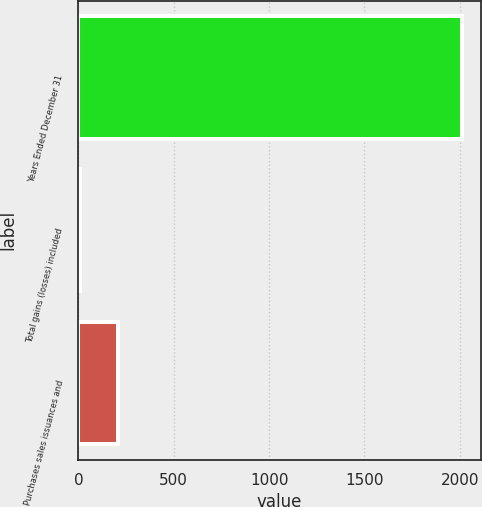Convert chart to OTSL. <chart><loc_0><loc_0><loc_500><loc_500><bar_chart><fcel>Years Ended December 31<fcel>Total gains (losses) included<fcel>Purchases sales issuances and<nl><fcel>2009<fcel>10<fcel>209.9<nl></chart> 